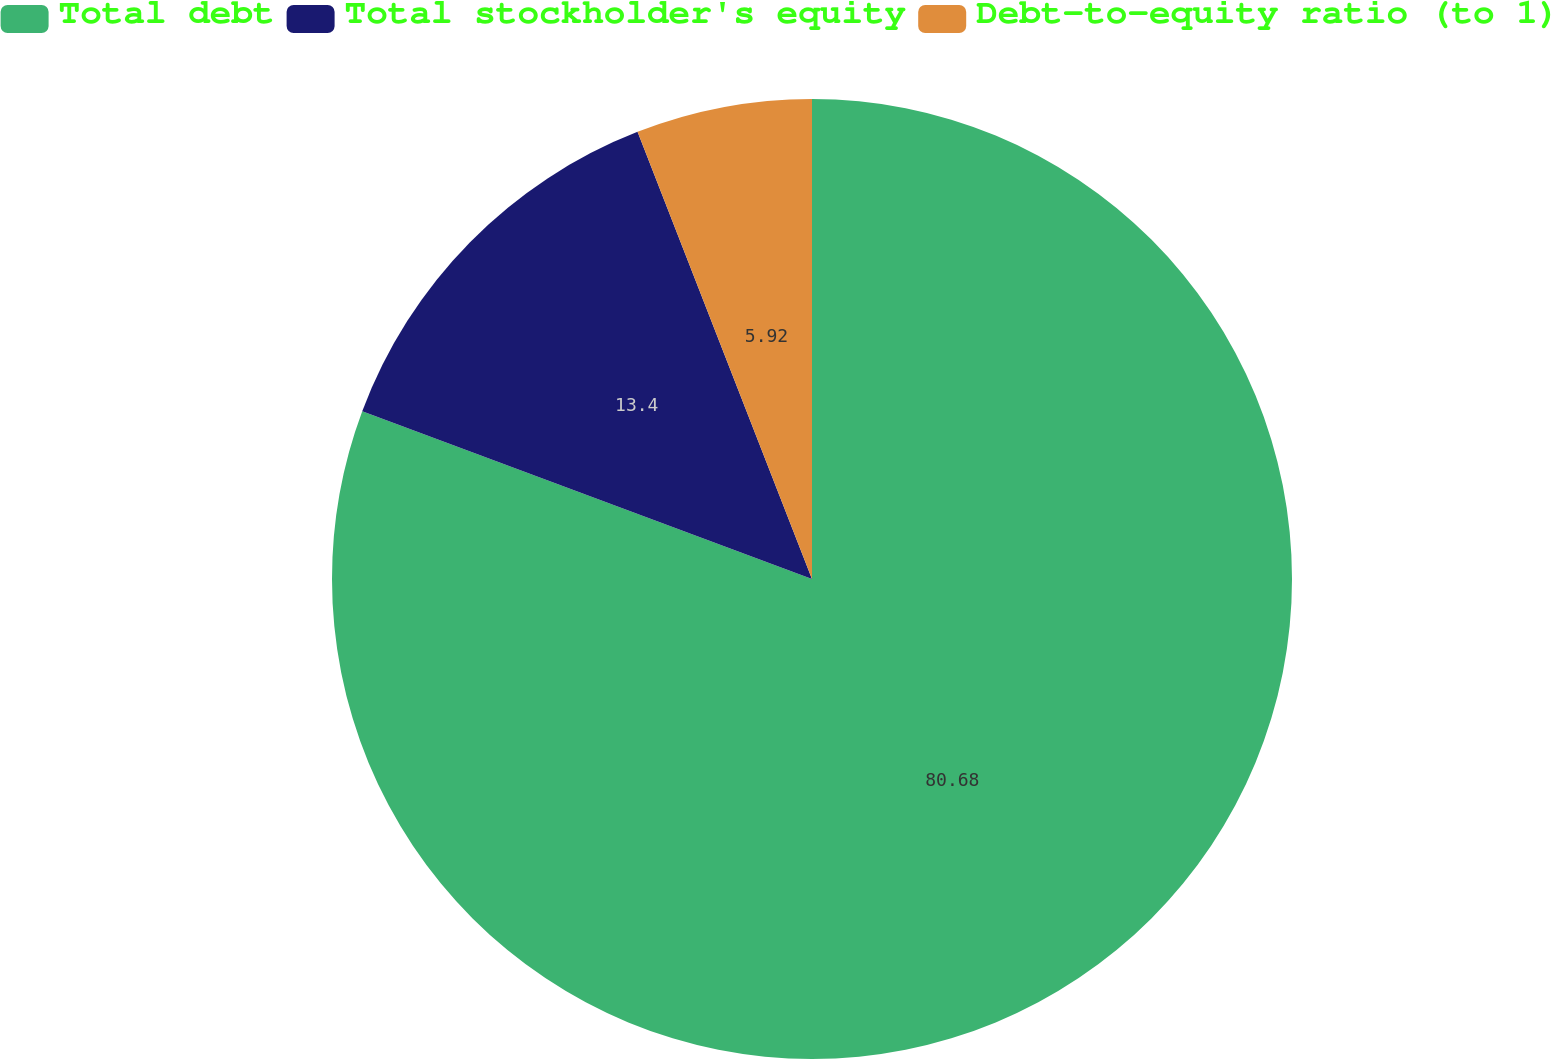Convert chart to OTSL. <chart><loc_0><loc_0><loc_500><loc_500><pie_chart><fcel>Total debt<fcel>Total stockholder's equity<fcel>Debt-to-equity ratio (to 1)<nl><fcel>80.68%<fcel>13.4%<fcel>5.92%<nl></chart> 